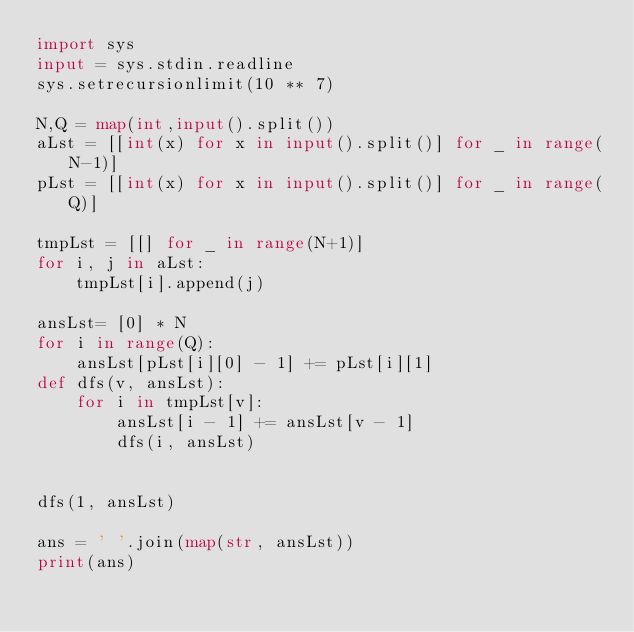<code> <loc_0><loc_0><loc_500><loc_500><_Python_>import sys
input = sys.stdin.readline
sys.setrecursionlimit(10 ** 7)

N,Q = map(int,input().split())
aLst = [[int(x) for x in input().split()] for _ in range(N-1)]
pLst = [[int(x) for x in input().split()] for _ in range(Q)]

tmpLst = [[] for _ in range(N+1)]
for i, j in aLst:
    tmpLst[i].append(j)

ansLst= [0] * N
for i in range(Q):
    ansLst[pLst[i][0] - 1] += pLst[i][1]
def dfs(v, ansLst):
    for i in tmpLst[v]:
        ansLst[i - 1] += ansLst[v - 1]
        dfs(i, ansLst)


dfs(1, ansLst)

ans = ' '.join(map(str, ansLst))
print(ans)
			</code> 